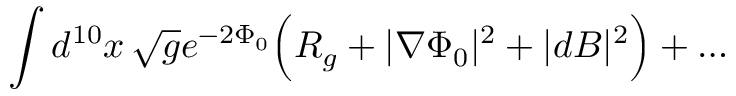<formula> <loc_0><loc_0><loc_500><loc_500>\int d ^ { 1 0 } x \, \sqrt { g } e ^ { - 2 \Phi _ { 0 } } \left ( R _ { g } + | \nabla \Phi _ { 0 } | ^ { 2 } + | d B | ^ { 2 } \right ) + \dots</formula> 